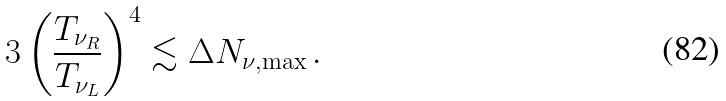Convert formula to latex. <formula><loc_0><loc_0><loc_500><loc_500>3 \left ( \frac { T _ { \nu _ { R } } } { T _ { \nu _ { L } } } \right ) ^ { 4 } \lesssim \Delta N _ { \nu , \max } \, .</formula> 